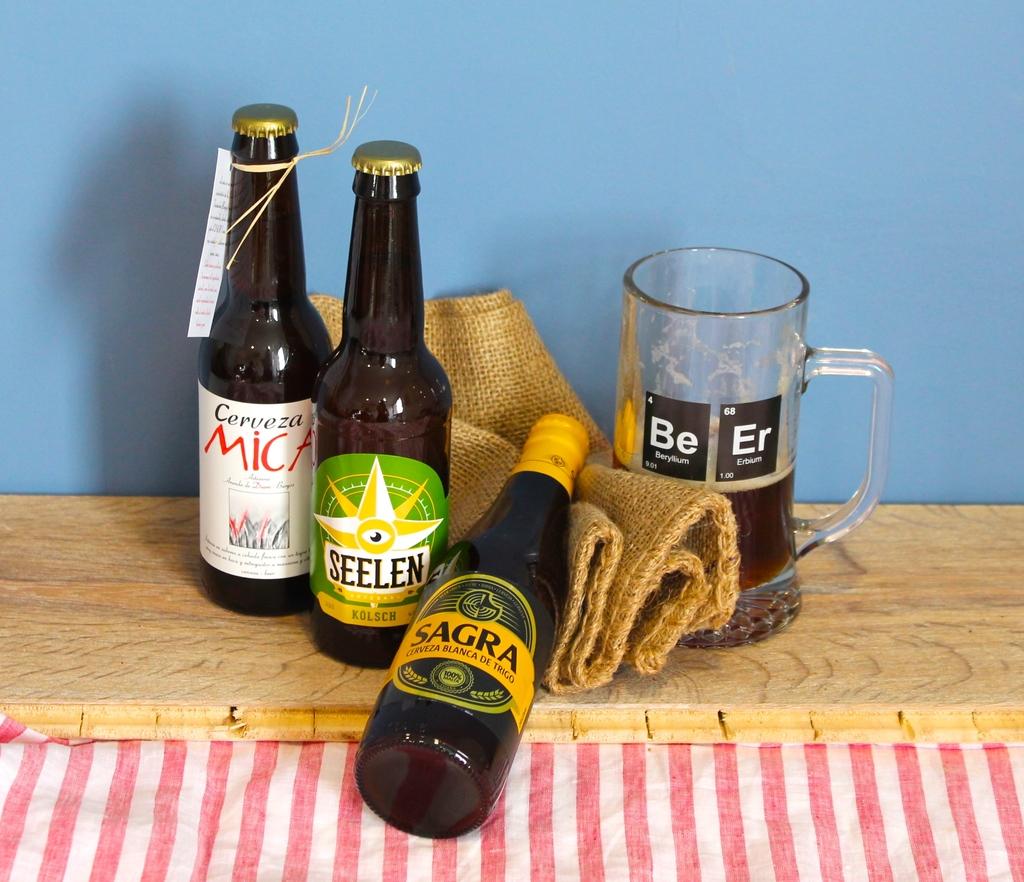Which is the seelen bottle?
Make the answer very short. Middle. What does the cup say?
Make the answer very short. Beer. 